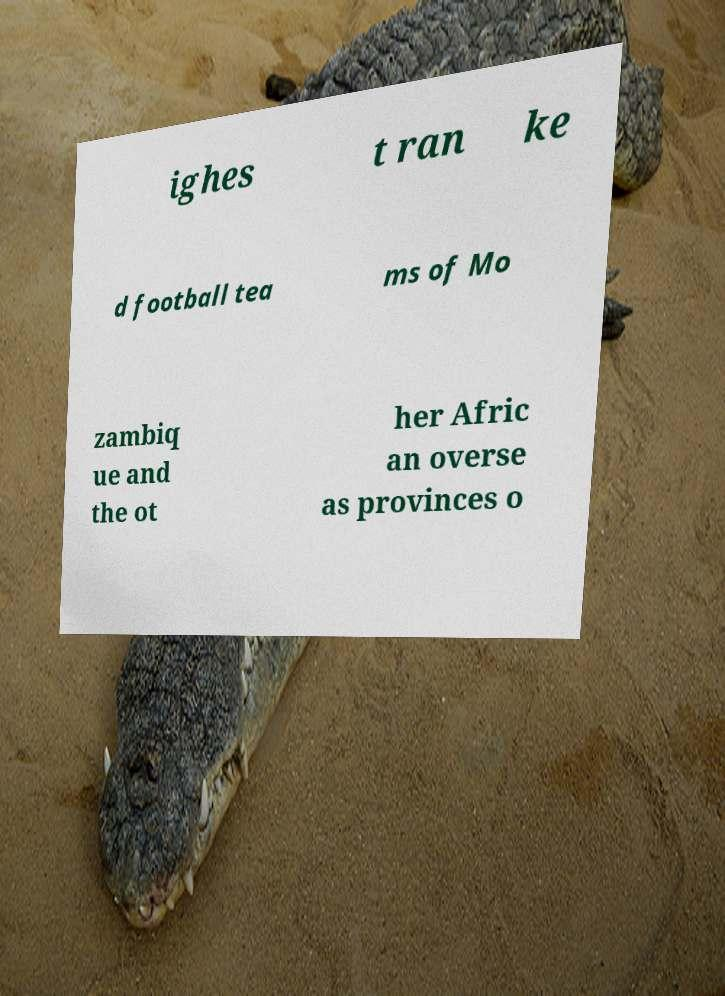What messages or text are displayed in this image? I need them in a readable, typed format. ighes t ran ke d football tea ms of Mo zambiq ue and the ot her Afric an overse as provinces o 